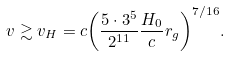<formula> <loc_0><loc_0><loc_500><loc_500>v \gtrsim v _ { H } = c { \left ( \frac { 5 \cdot 3 ^ { 5 } } { 2 ^ { 1 1 } } \frac { H _ { 0 } } { c } r _ { g } \right ) } ^ { 7 / 1 6 } .</formula> 